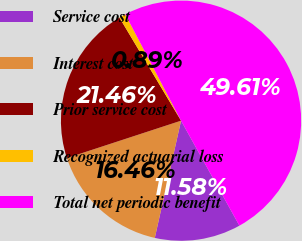Convert chart. <chart><loc_0><loc_0><loc_500><loc_500><pie_chart><fcel>Service cost<fcel>Interest cost<fcel>Prior service cost<fcel>Recognized actuarial loss<fcel>Total net periodic benefit<nl><fcel>11.58%<fcel>16.46%<fcel>21.46%<fcel>0.89%<fcel>49.61%<nl></chart> 